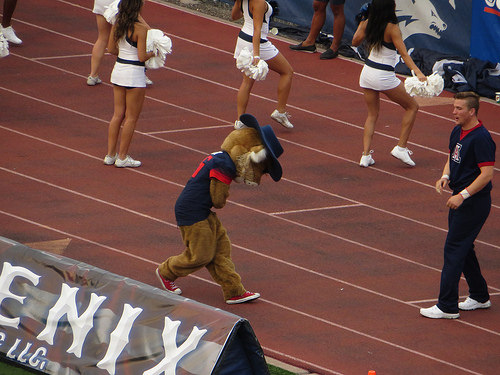<image>
Is there a costume on the man? No. The costume is not positioned on the man. They may be near each other, but the costume is not supported by or resting on top of the man. Is the character behind the cheerleader? Yes. From this viewpoint, the character is positioned behind the cheerleader, with the cheerleader partially or fully occluding the character. Where is the man in relation to the girl? Is it to the left of the girl? No. The man is not to the left of the girl. From this viewpoint, they have a different horizontal relationship. 